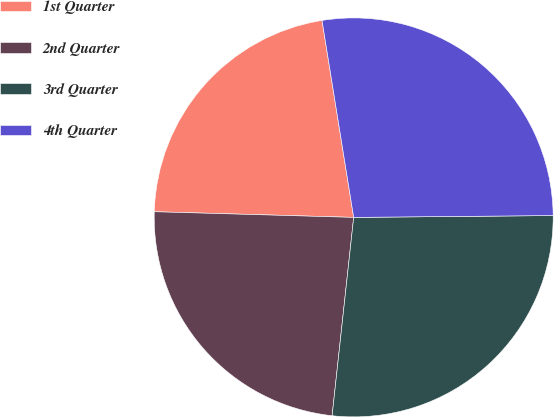<chart> <loc_0><loc_0><loc_500><loc_500><pie_chart><fcel>1st Quarter<fcel>2nd Quarter<fcel>3rd Quarter<fcel>4th Quarter<nl><fcel>22.01%<fcel>23.73%<fcel>26.87%<fcel>27.39%<nl></chart> 